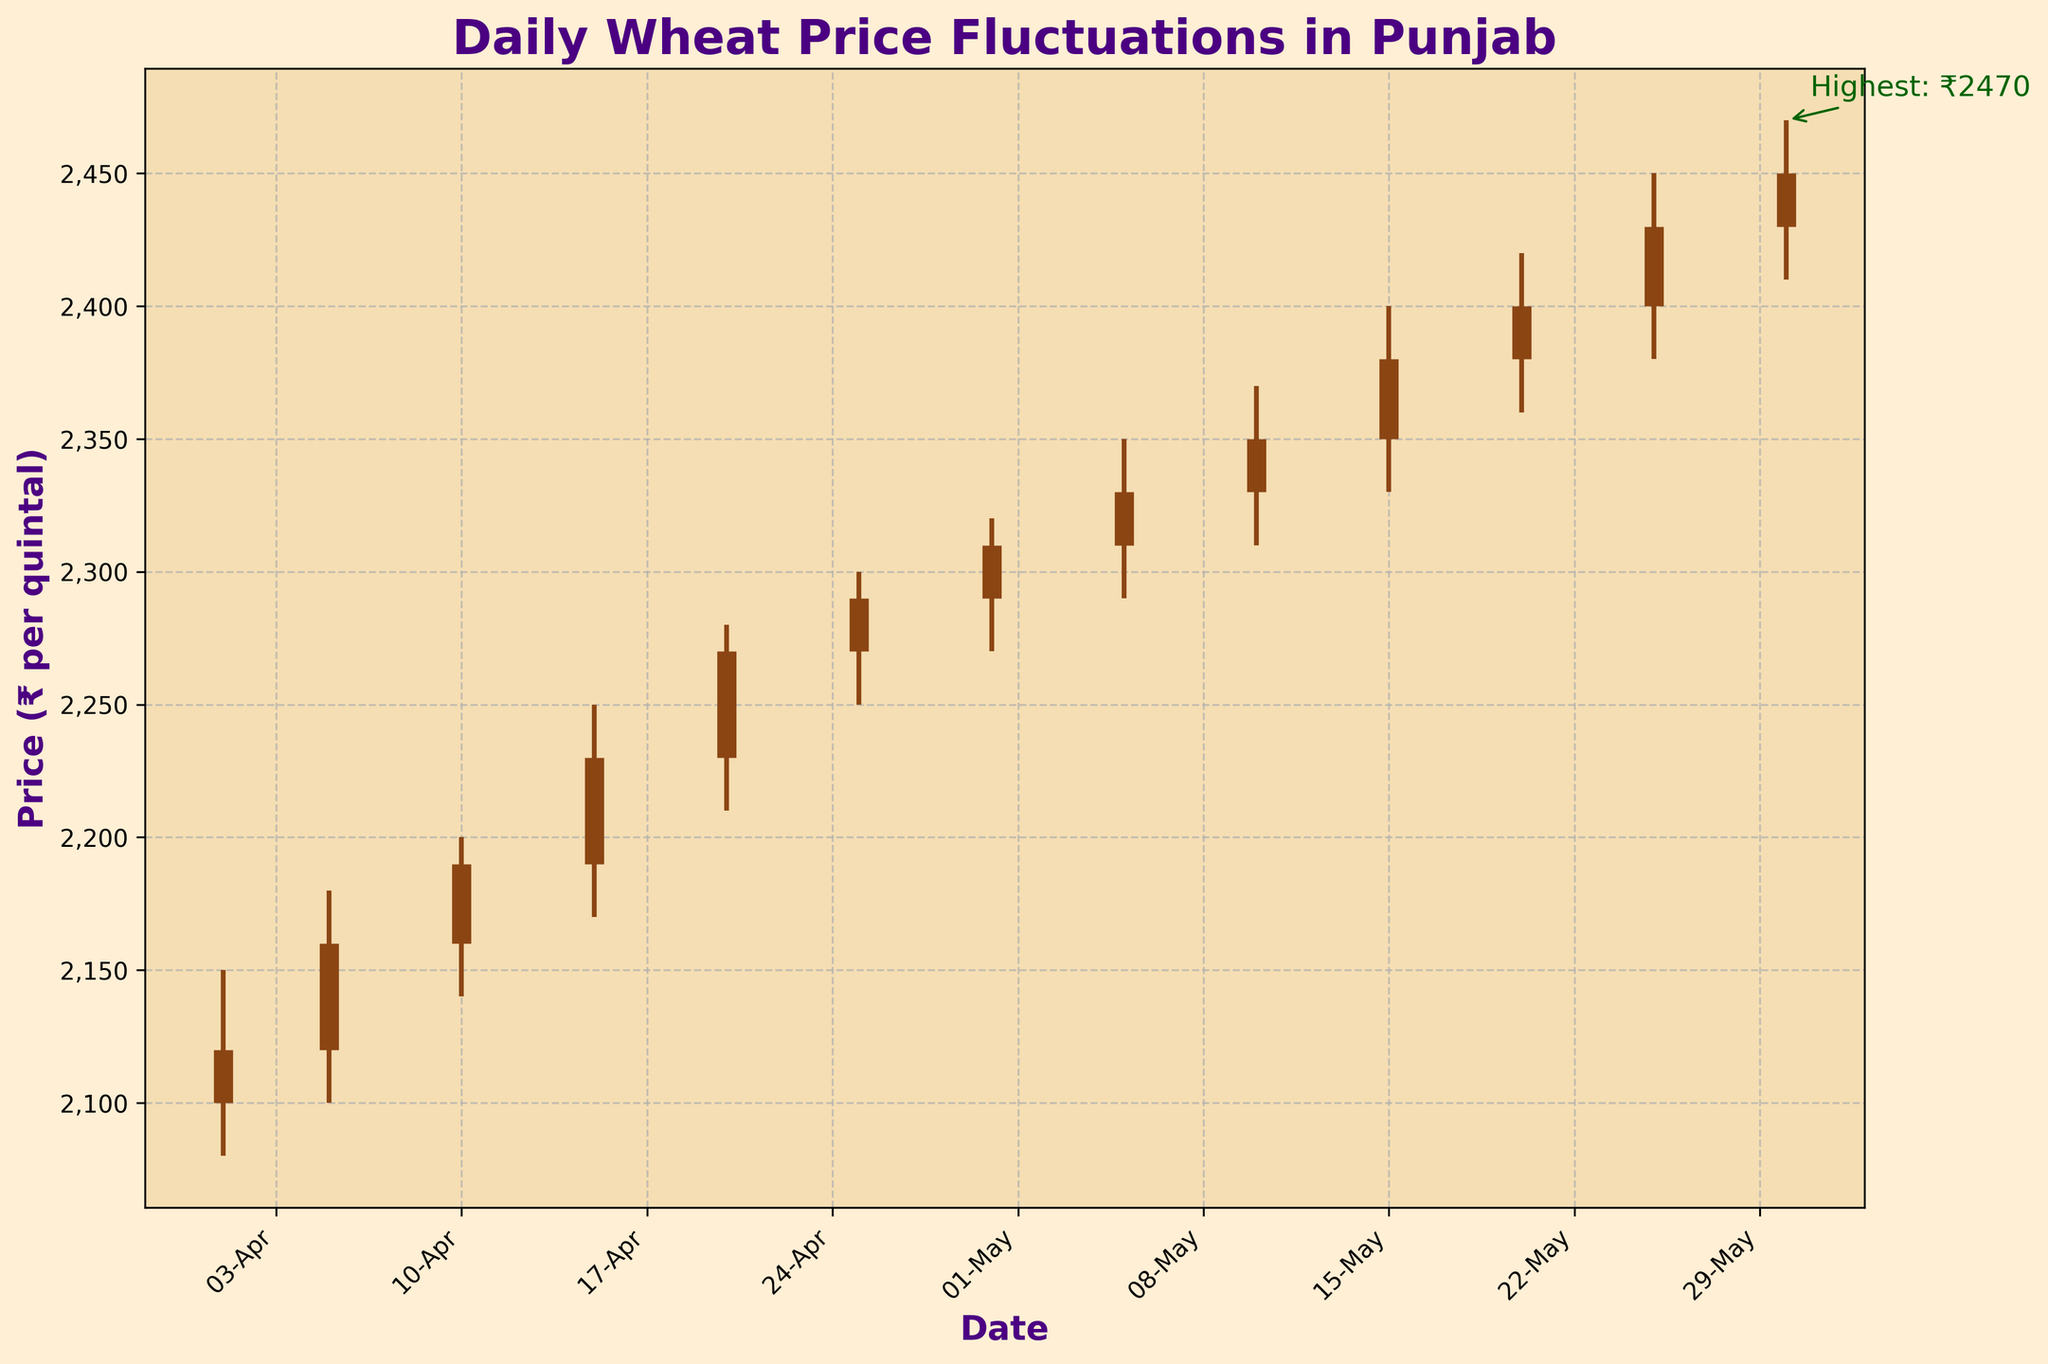What is the title of the figure? The title of the figure can be seen at the top of the plot.
Answer: Daily Wheat Price Fluctuations in Punjab What is the highest price recorded during the season? The highest price recorded can be found by identifying the peak of the highest vertical line in the plot, which is annotated with a text label.
Answer: ₹2470 On which date was the highest price recorded? Look for the annotation arrow pointing to the peak value, which marks the highest price and the corresponding date.
Answer: 30-May What is the price range on 2023-04-01? The price range is the difference between the highest and lowest prices on that date. The high and low values can be read directly from the plotted lines.
Answer: 2150 - 2080 = ₹70 What was the closing price on 2023-05-05? The closing price is found at the end of each vertical bar, specifically the thicker part of the bar, on the specified date.
Answer: ₹2330 How much did the price increase from 2023-04-01 to 2023-05-30? Subtract the opening price on 2023-04-01 from the closing price on 2023-05-30.
Answer: 2450 - 2100 = ₹350 What is the average closing price for the month of April? Add the closing prices for all dates in April and divide by the number of dates. (2120 + 2160 + 2190 + 2230 + 2270 + 2290) / 6
Answer: ₹2210 Which date had the smallest fluctuation in prices, and what was the fluctuation amount? The smallest fluctuation can be determined by finding the smallest difference between high and low prices on any date.
Answer: 2023-04-25; 50 (2300 - 2250) Did the price ever decrease between consecutive dates during the season? Compare the closing prices of consecutive dates to check if any closing price is less than the previous date's closing price.
Answer: No During which period did the price show a consistent increase without any decreases? Look for a consecutive sequence of increasing closing prices in the chart. One such period spans from 2023-04-01 to 2023-04-25.
Answer: 2023-04-01 to 2023-04-25 